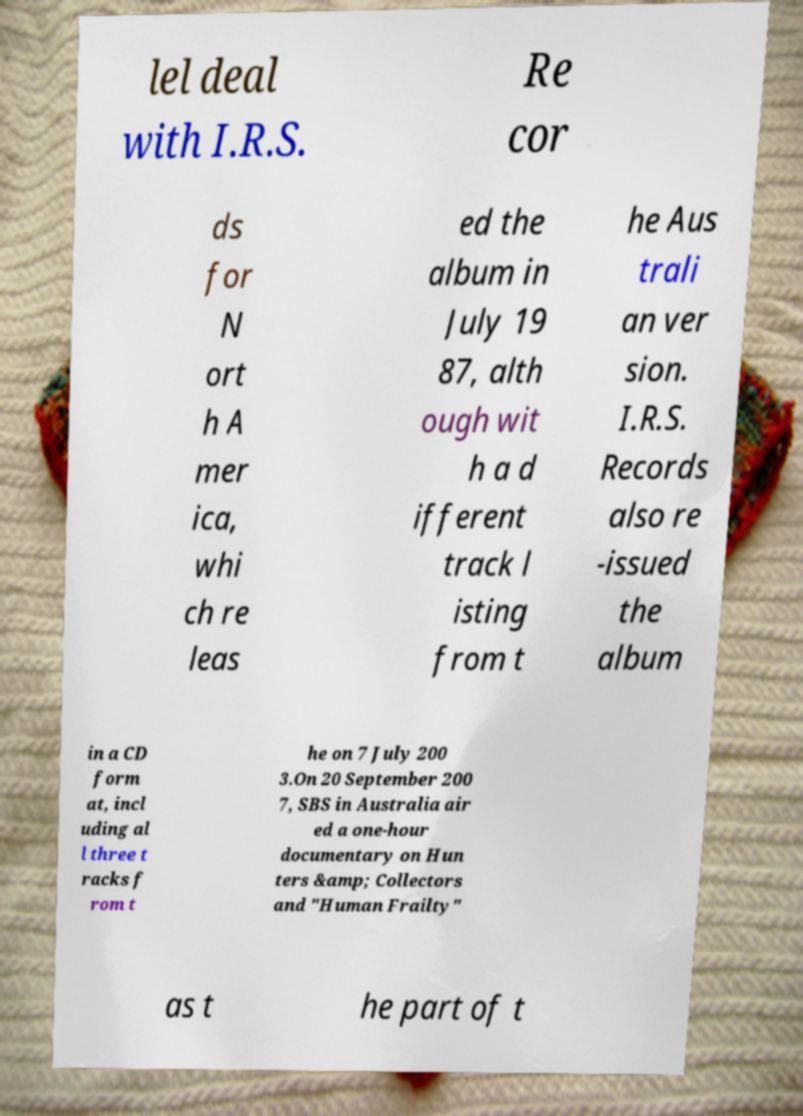Could you assist in decoding the text presented in this image and type it out clearly? lel deal with I.R.S. Re cor ds for N ort h A mer ica, whi ch re leas ed the album in July 19 87, alth ough wit h a d ifferent track l isting from t he Aus trali an ver sion. I.R.S. Records also re -issued the album in a CD form at, incl uding al l three t racks f rom t he on 7 July 200 3.On 20 September 200 7, SBS in Australia air ed a one-hour documentary on Hun ters &amp; Collectors and "Human Frailty" as t he part of t 